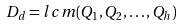Convert formula to latex. <formula><loc_0><loc_0><loc_500><loc_500>D _ { d } = l c m ( Q _ { 1 } , Q _ { 2 } , \dots , Q _ { h } )</formula> 